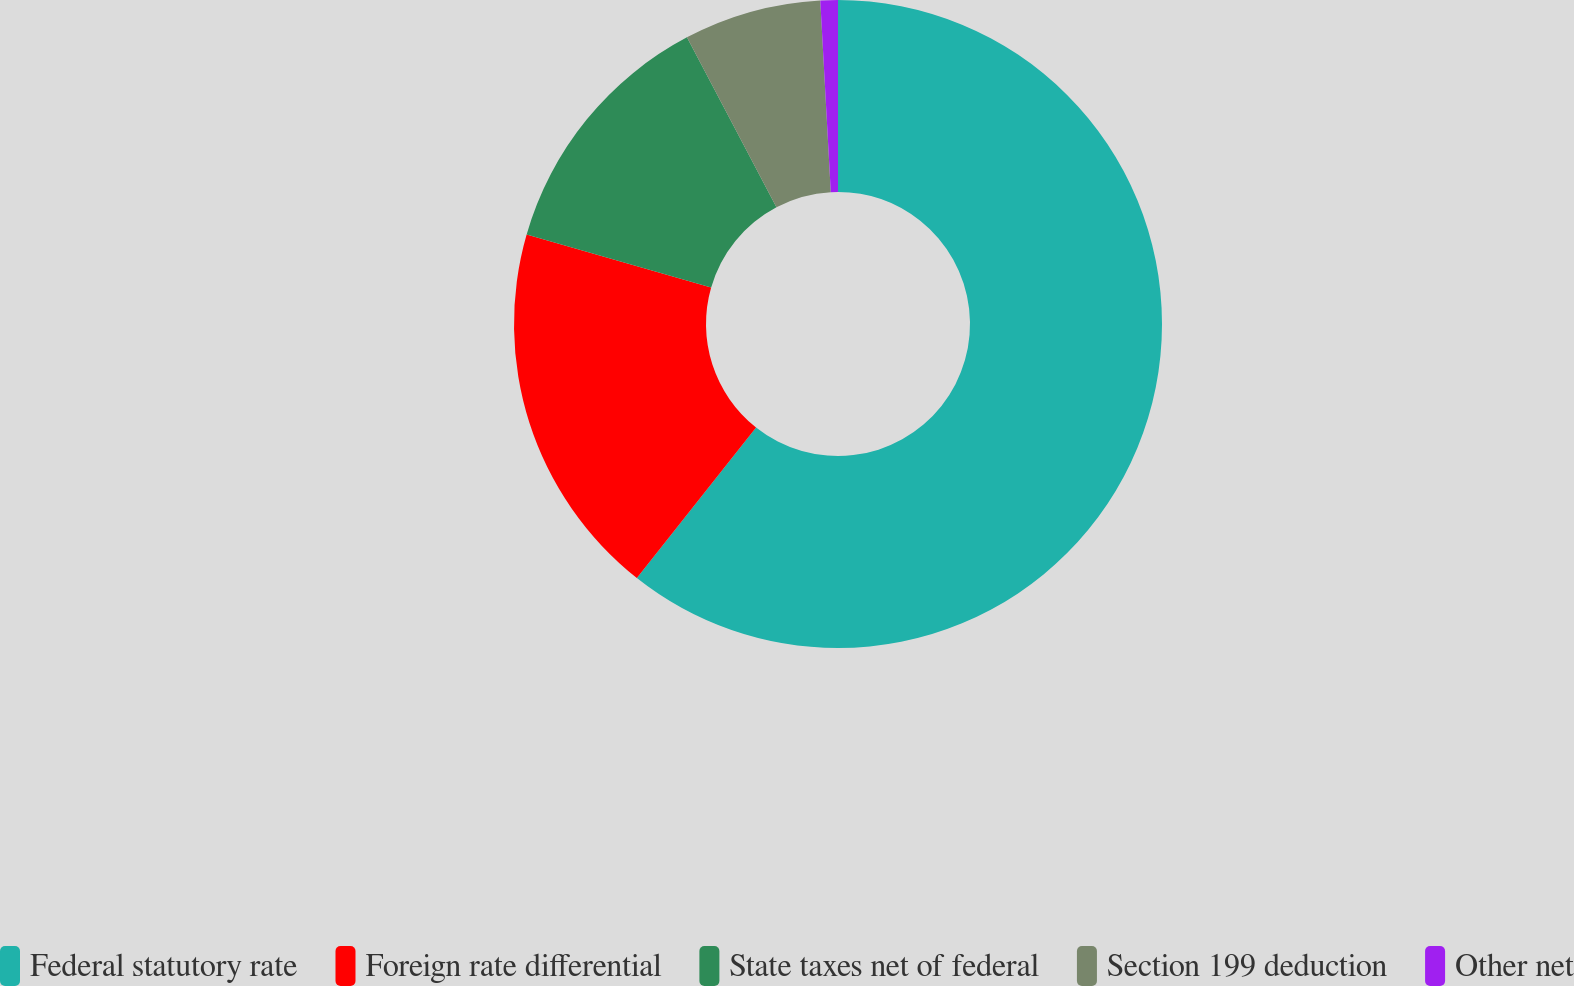<chart> <loc_0><loc_0><loc_500><loc_500><pie_chart><fcel>Federal statutory rate<fcel>Foreign rate differential<fcel>State taxes net of federal<fcel>Section 199 deduction<fcel>Other net<nl><fcel>60.66%<fcel>18.8%<fcel>12.82%<fcel>6.85%<fcel>0.87%<nl></chart> 